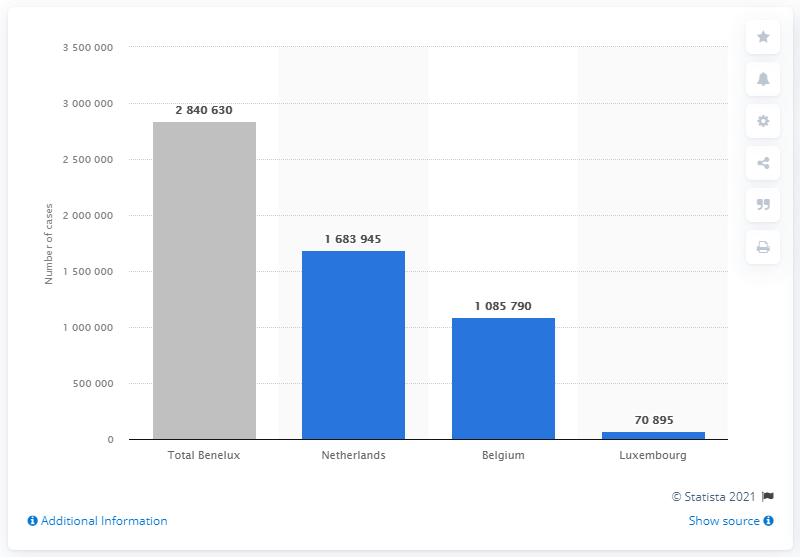Identify some key points in this picture. Luxembourg has not been affected by the COVID-19 pandemic. As of June 30, 2021, there were a total of 168,394 cases of COVID-19 in the Netherlands. 